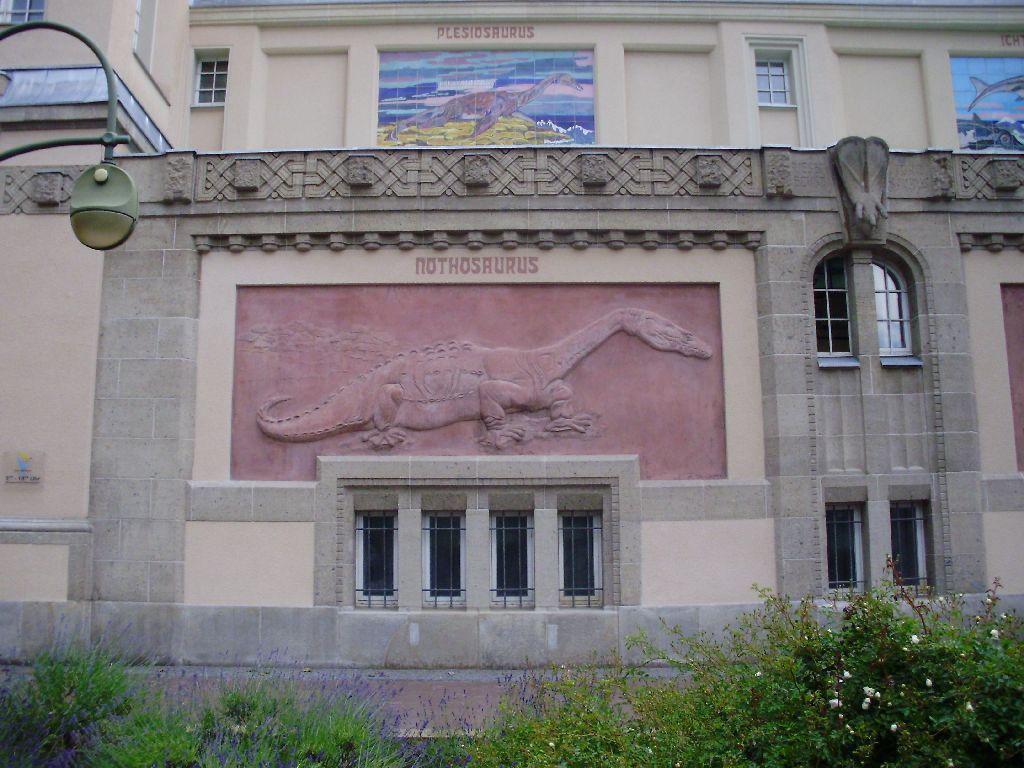What type of structure is present in the image? There is a building in the image. What feature can be seen on the building? The building has windows. What type of artwork is visible in the image? There is a painting in the image. What type of structures are related to dinosaurs in the image? There are dinosaur structures in the image. Where is the light located in the image? There is a light towards the left side of the image. What type of vegetation is present at the bottom of the image? There are plants at the bottom of the image. Can you tell me how many basketballs are being held by the bear in the image? There is no bear or basketball present in the image. What type of toothbrush is being used by the person in the image? There is no toothbrush visible in the image. 